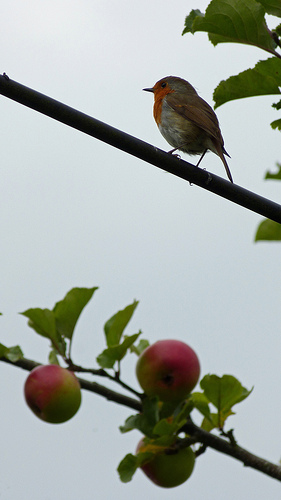What time of year does this image likely depict? Given the presence of apples that seem to be nearing full ripeness, this image likely depicts late summer or early autumn, the typical season for apple harvesting in many regions. 